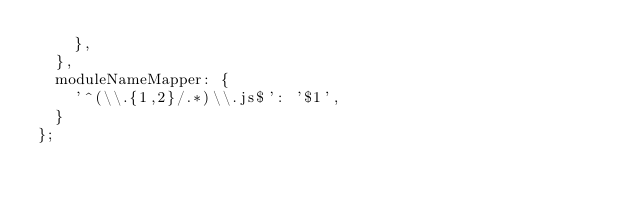<code> <loc_0><loc_0><loc_500><loc_500><_JavaScript_>    },
  },
  moduleNameMapper: {
    '^(\\.{1,2}/.*)\\.js$': '$1',
  }
};
</code> 